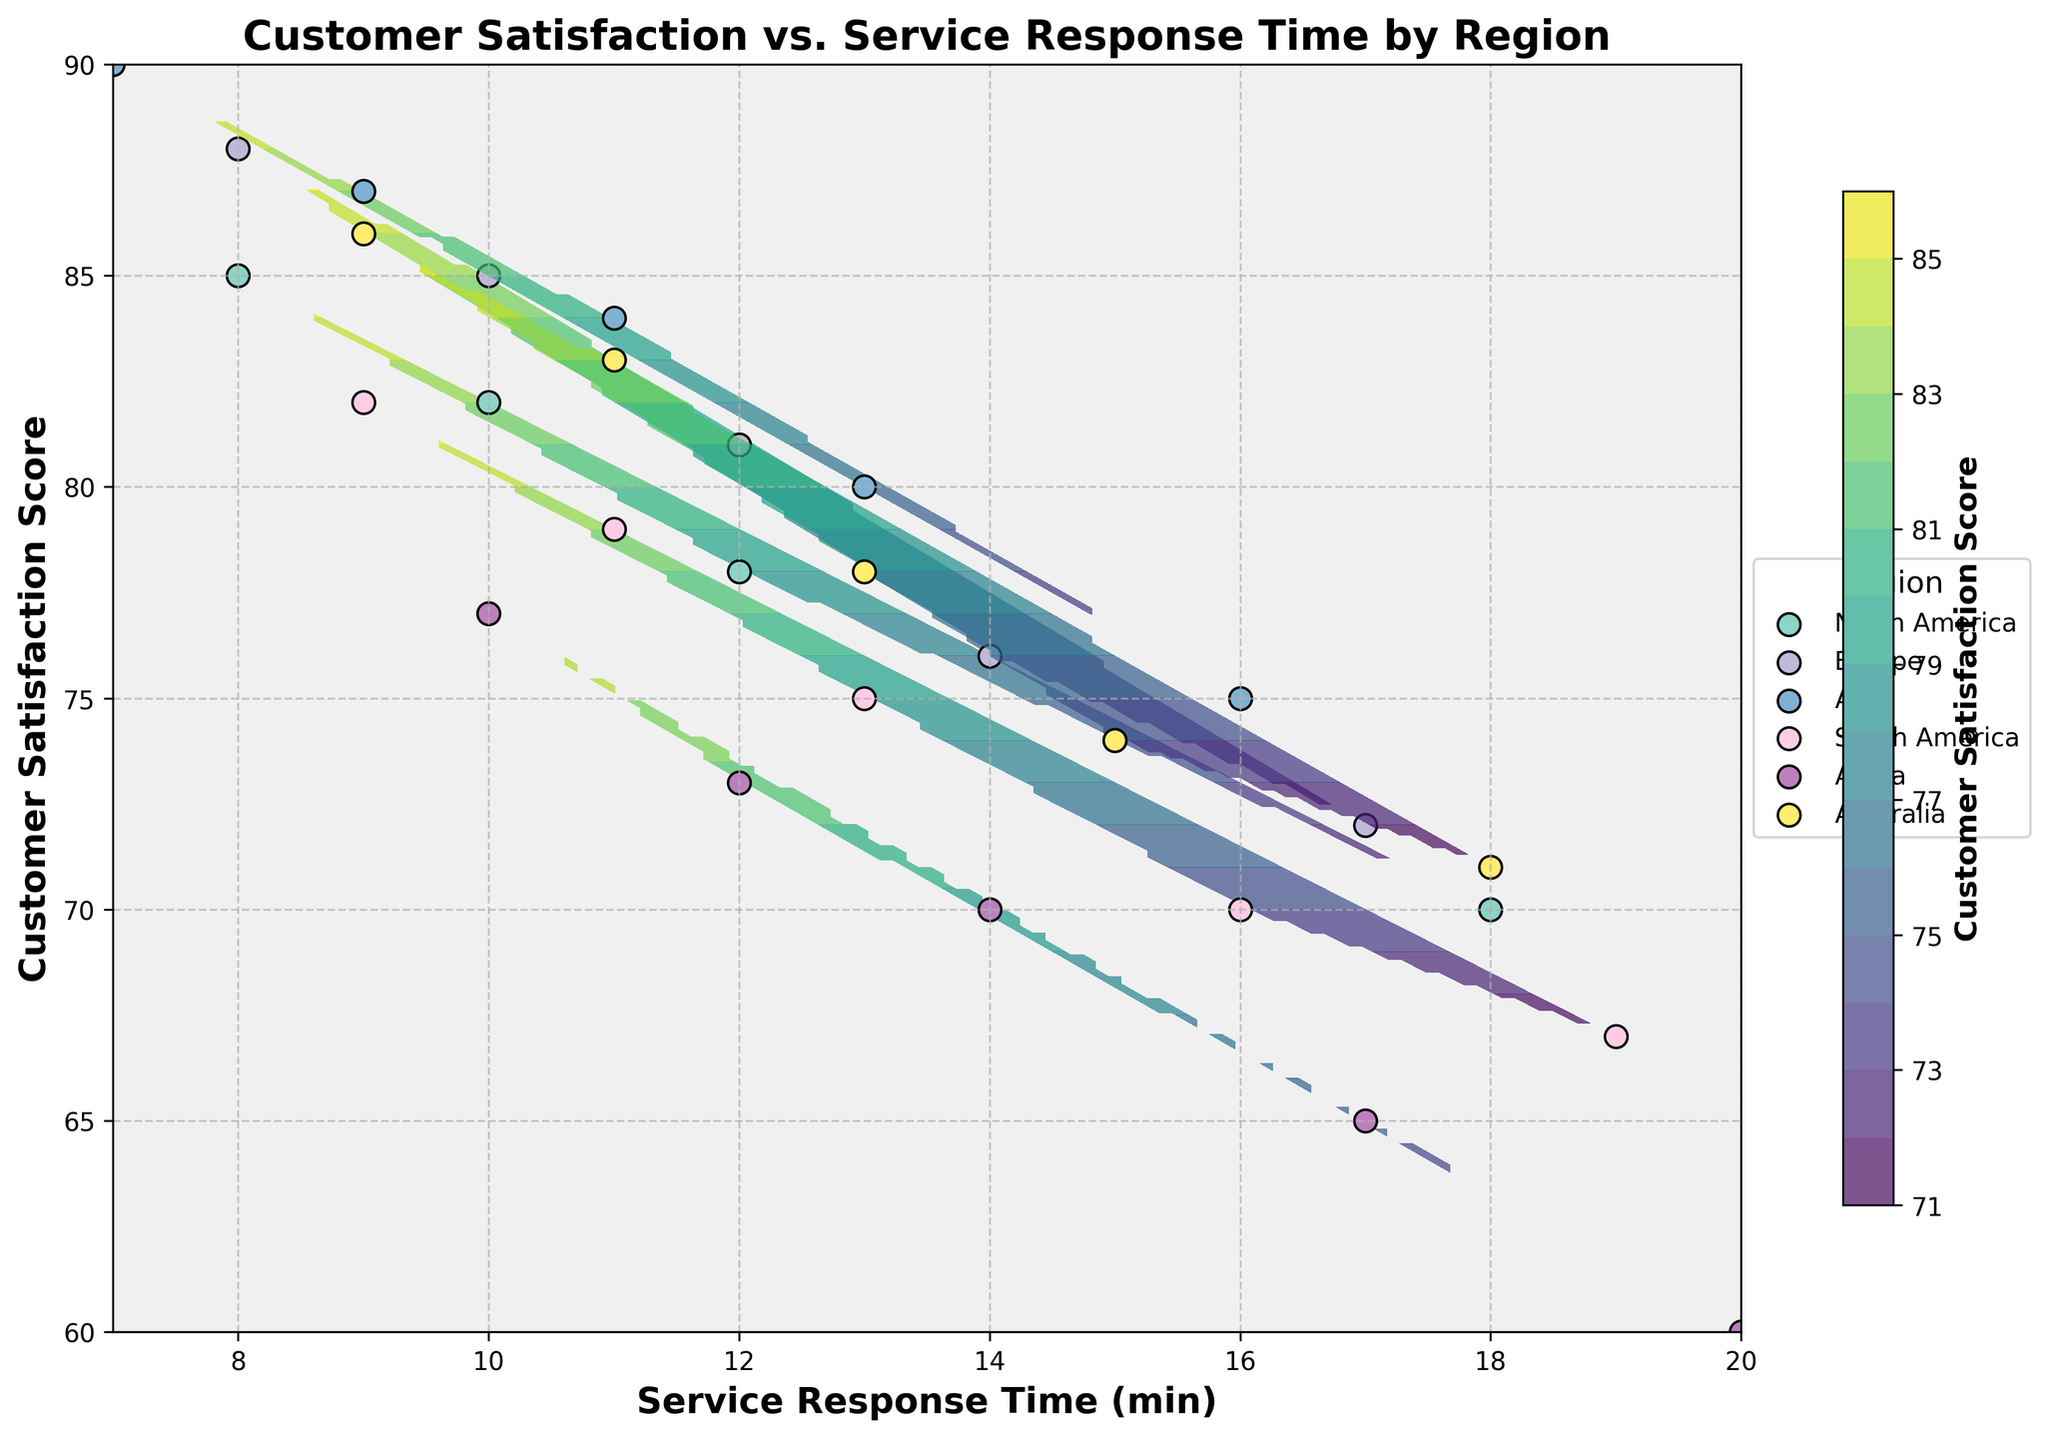What is the title of the plot? The title is displayed at the top-center of the plot.
Answer: Customer Satisfaction vs. Service Response Time by Region What are the x and y labels in the plot? The labels are displayed along the axes. The x-axis label is located horizontally at the bottom while the y-axis label is located vertically on the left side.
Answer: Service Response Time (min) and Customer Satisfaction Score Which region has the lowest customer satisfaction score for the highest service response time displayed? From the contour plot, the lowest satisfaction score corresponds to the region with the darkest area.
Answer: Africa Which region achieves a customer satisfaction score of 90? By looking at the scatter points and the color contours, satisfaction scores around 90 can be observed at the start of the plotted points.
Answer: Asia What is the general trend between service response time and customer satisfaction score across all regions? Observing the overall pattern from the contour lines and scatter points, customer satisfaction tends to decrease as service response time increases.
Answer: Negative correlation Which region has the highest customer satisfaction score for a service response time of around 10 minutes? By comparing the points across regions, the highest points around a 10-minute response can be identified by the color shadings and scatter positions.
Answer: Asia What is the average customer satisfaction score in Europe for response times listed? List the scores for Europe from the data table and compute their average (88+85+81+76+72)/5.
Answer: 80.4 How does customer satisfaction in North America compare to Europe for a 12-minute service response time? Compare the plotted data points for a 12-minute response time in both regions by looking at their corresponding y-values.
Answer: North America has a lower satisfaction score Which region shows the smallest decline in customer satisfaction as service response time increases from 8 to 18 minutes? Examine the contour plot and look at how tightly clustered the lines are; smaller declines will have less steep slopes.
Answer: Europe What is the difference in customer satisfaction scores between Asia and Africa at around 13 minutes of service response time? Identify the points for both regions at 13 minutes (if exact points are not available, interpolate visually) and calculate the difference.
Answer: Around 14 (possibly 80 for Asia and 66 for Africa) 